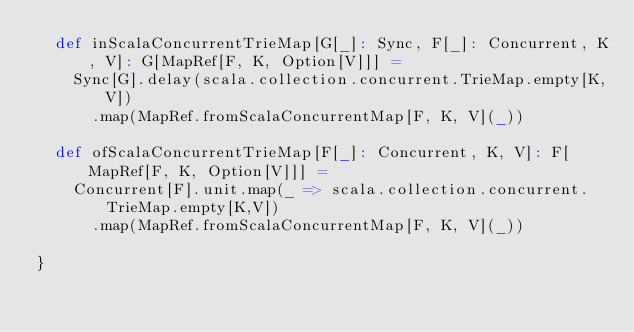Convert code to text. <code><loc_0><loc_0><loc_500><loc_500><_Scala_>  def inScalaConcurrentTrieMap[G[_]: Sync, F[_]: Concurrent, K, V]: G[MapRef[F, K, Option[V]]] = 
    Sync[G].delay(scala.collection.concurrent.TrieMap.empty[K,V])
      .map(MapRef.fromScalaConcurrentMap[F, K, V](_))

  def ofScalaConcurrentTrieMap[F[_]: Concurrent, K, V]: F[MapRef[F, K, Option[V]]] = 
    Concurrent[F].unit.map(_ => scala.collection.concurrent.TrieMap.empty[K,V])
      .map(MapRef.fromScalaConcurrentMap[F, K, V](_))

}</code> 